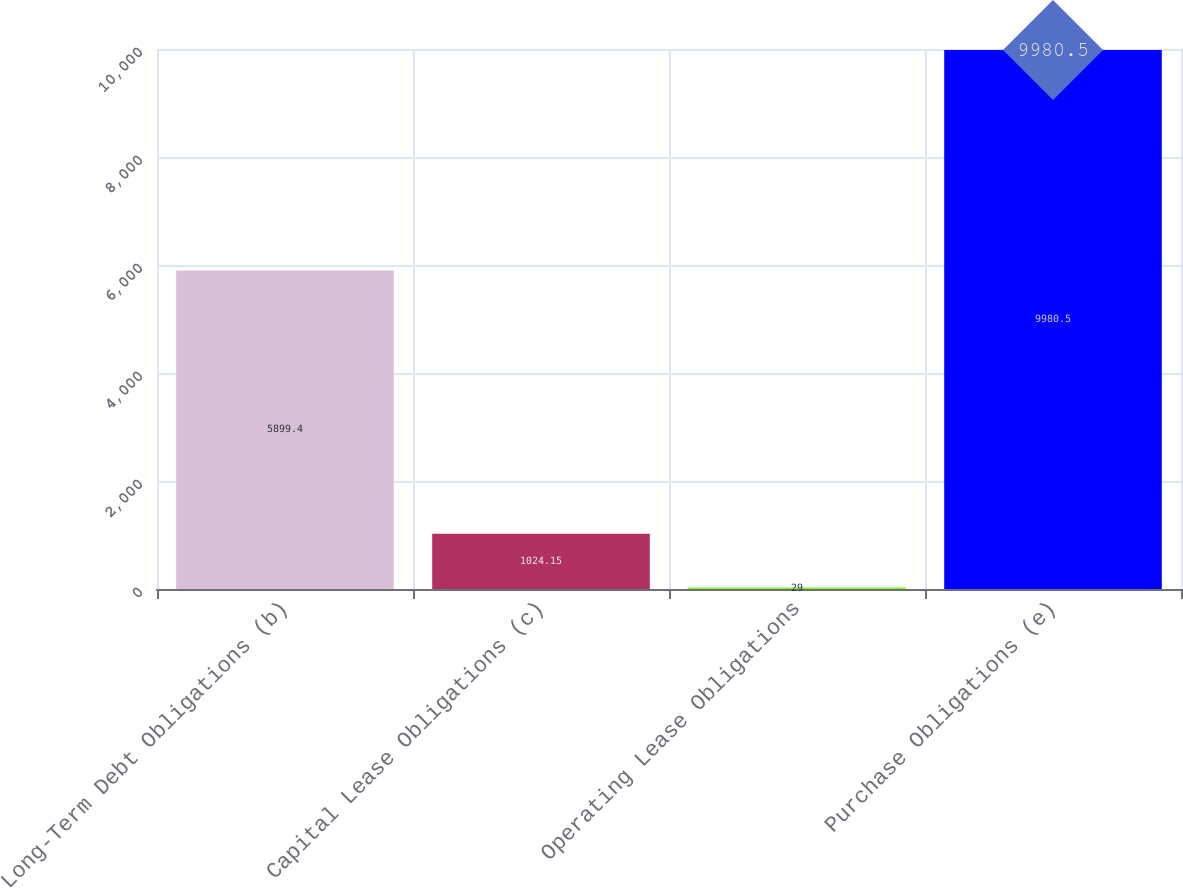<chart> <loc_0><loc_0><loc_500><loc_500><bar_chart><fcel>Long-Term Debt Obligations (b)<fcel>Capital Lease Obligations (c)<fcel>Operating Lease Obligations<fcel>Purchase Obligations (e)<nl><fcel>5899.4<fcel>1024.15<fcel>29<fcel>9980.5<nl></chart> 